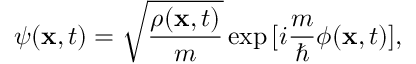<formula> <loc_0><loc_0><loc_500><loc_500>\psi ( { x } , t ) = \sqrt { \frac { \rho ( { x } , t ) } { m } } \exp { [ i \frac { m } { } \phi ( { x } , t ) ] } ,</formula> 